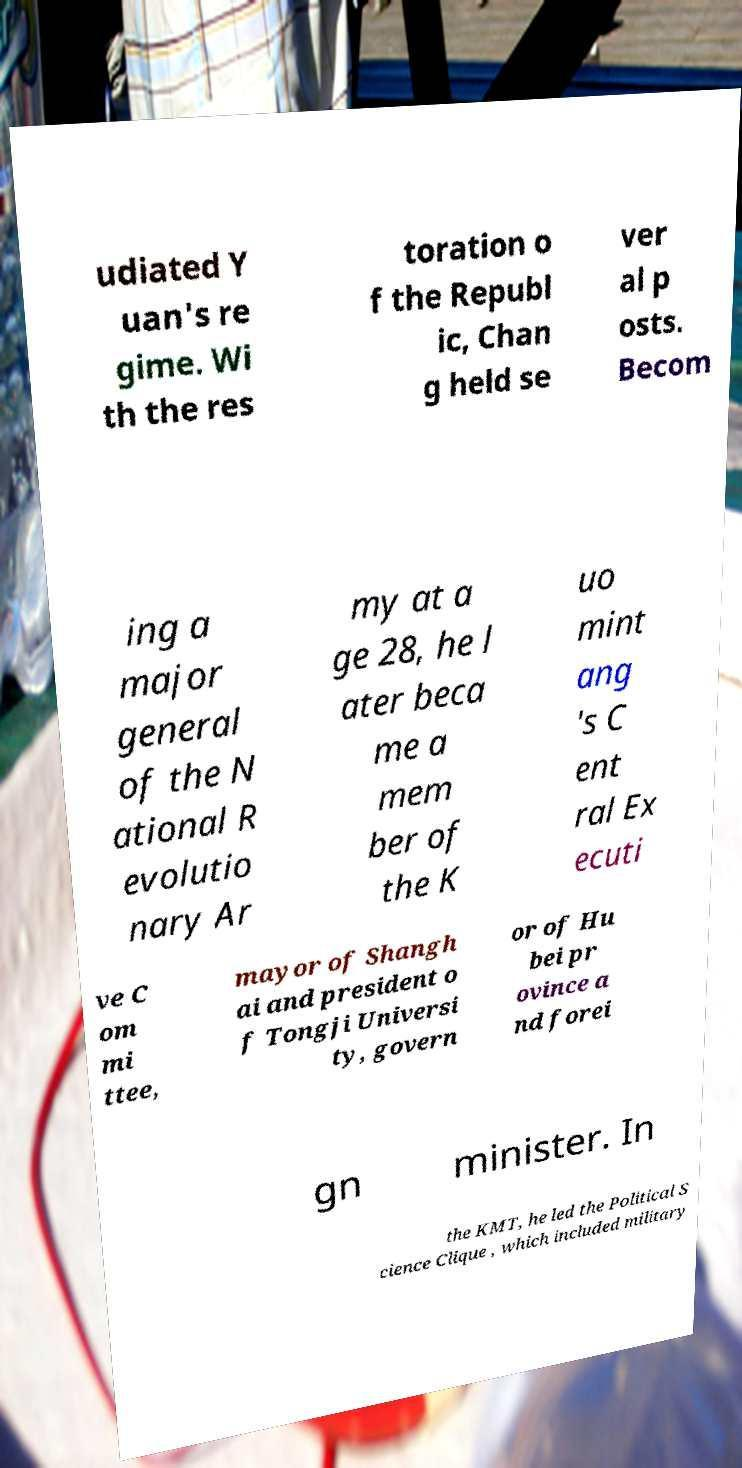Please identify and transcribe the text found in this image. udiated Y uan's re gime. Wi th the res toration o f the Republ ic, Chan g held se ver al p osts. Becom ing a major general of the N ational R evolutio nary Ar my at a ge 28, he l ater beca me a mem ber of the K uo mint ang 's C ent ral Ex ecuti ve C om mi ttee, mayor of Shangh ai and president o f Tongji Universi ty, govern or of Hu bei pr ovince a nd forei gn minister. In the KMT, he led the Political S cience Clique , which included military 